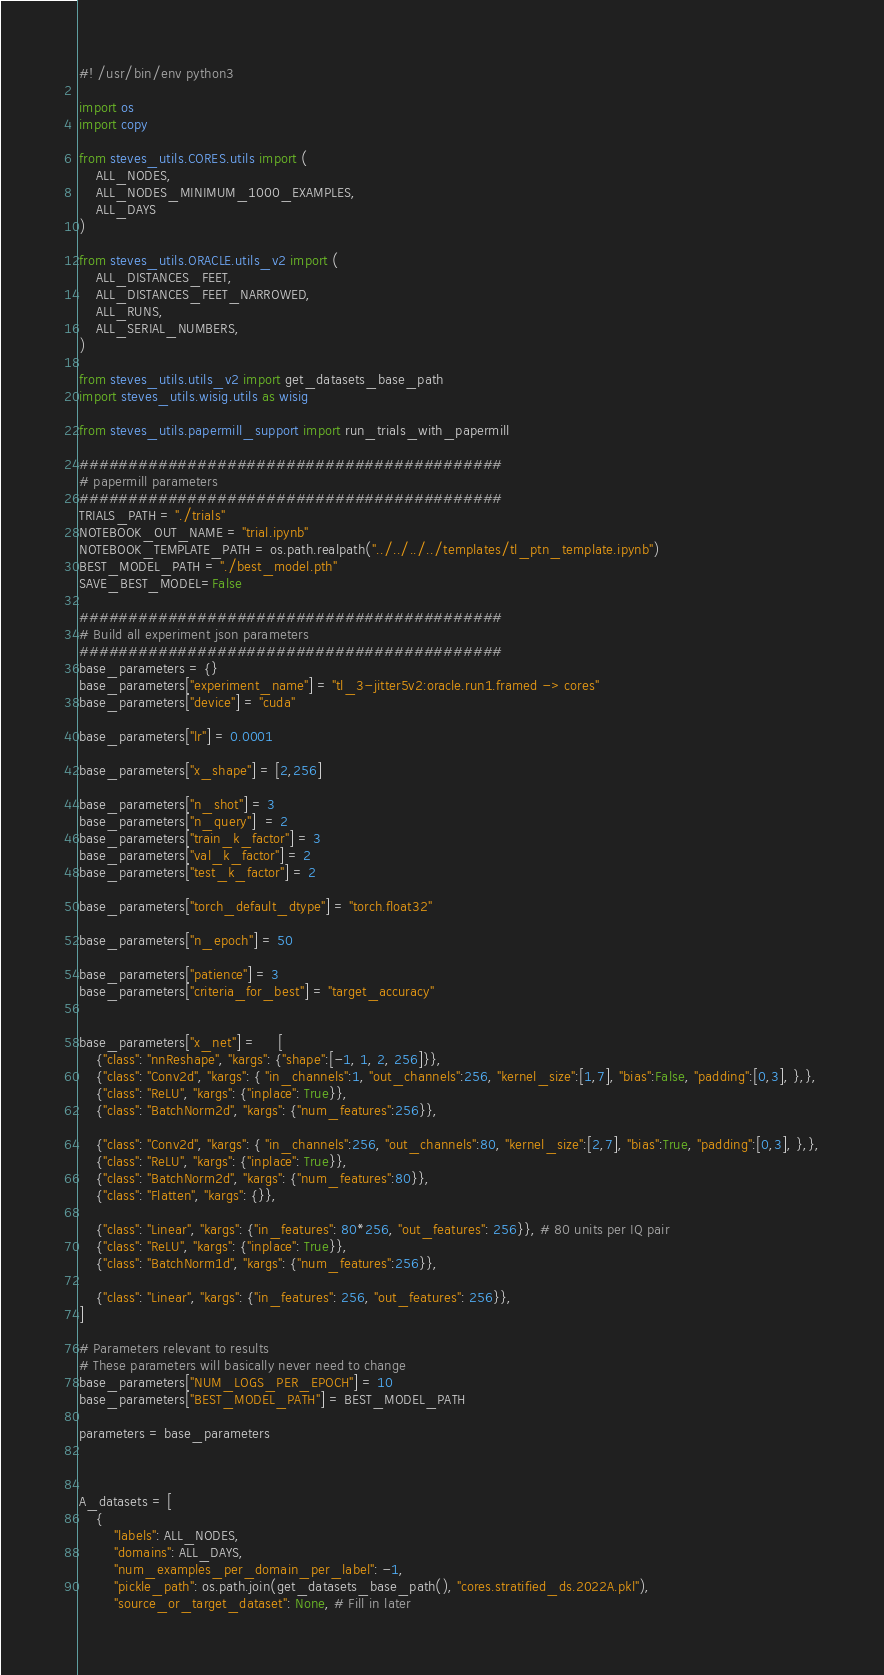<code> <loc_0><loc_0><loc_500><loc_500><_Python_>#! /usr/bin/env python3

import os
import copy

from steves_utils.CORES.utils import (
    ALL_NODES,
    ALL_NODES_MINIMUM_1000_EXAMPLES,
    ALL_DAYS
)

from steves_utils.ORACLE.utils_v2 import (
    ALL_DISTANCES_FEET,
    ALL_DISTANCES_FEET_NARROWED,
    ALL_RUNS,
    ALL_SERIAL_NUMBERS,
)

from steves_utils.utils_v2 import get_datasets_base_path
import steves_utils.wisig.utils as wisig

from steves_utils.papermill_support import run_trials_with_papermill

###########################################
# papermill parameters
###########################################
TRIALS_PATH = "./trials"
NOTEBOOK_OUT_NAME = "trial.ipynb"
NOTEBOOK_TEMPLATE_PATH = os.path.realpath("../../../../templates/tl_ptn_template.ipynb")
BEST_MODEL_PATH = "./best_model.pth"
SAVE_BEST_MODEL=False

###########################################
# Build all experiment json parameters
###########################################
base_parameters = {}
base_parameters["experiment_name"] = "tl_3-jitter5v2:oracle.run1.framed -> cores"
base_parameters["device"] = "cuda"

base_parameters["lr"] = 0.0001

base_parameters["x_shape"] = [2,256]

base_parameters["n_shot"] = 3
base_parameters["n_query"]  = 2
base_parameters["train_k_factor"] = 3
base_parameters["val_k_factor"] = 2
base_parameters["test_k_factor"] = 2

base_parameters["torch_default_dtype"] = "torch.float32" 

base_parameters["n_epoch"] = 50

base_parameters["patience"] = 3
base_parameters["criteria_for_best"] = "target_accuracy"


base_parameters["x_net"] =     [
    {"class": "nnReshape", "kargs": {"shape":[-1, 1, 2, 256]}},
    {"class": "Conv2d", "kargs": { "in_channels":1, "out_channels":256, "kernel_size":[1,7], "bias":False, "padding":[0,3], },},
    {"class": "ReLU", "kargs": {"inplace": True}},
    {"class": "BatchNorm2d", "kargs": {"num_features":256}},

    {"class": "Conv2d", "kargs": { "in_channels":256, "out_channels":80, "kernel_size":[2,7], "bias":True, "padding":[0,3], },},
    {"class": "ReLU", "kargs": {"inplace": True}},
    {"class": "BatchNorm2d", "kargs": {"num_features":80}},
    {"class": "Flatten", "kargs": {}},

    {"class": "Linear", "kargs": {"in_features": 80*256, "out_features": 256}}, # 80 units per IQ pair
    {"class": "ReLU", "kargs": {"inplace": True}},
    {"class": "BatchNorm1d", "kargs": {"num_features":256}},

    {"class": "Linear", "kargs": {"in_features": 256, "out_features": 256}},
]

# Parameters relevant to results
# These parameters will basically never need to change
base_parameters["NUM_LOGS_PER_EPOCH"] = 10
base_parameters["BEST_MODEL_PATH"] = BEST_MODEL_PATH

parameters = base_parameters



A_datasets = [
    {
        "labels": ALL_NODES,
        "domains": ALL_DAYS,
        "num_examples_per_domain_per_label": -1,
        "pickle_path": os.path.join(get_datasets_base_path(), "cores.stratified_ds.2022A.pkl"),
        "source_or_target_dataset": None, # Fill in later</code> 